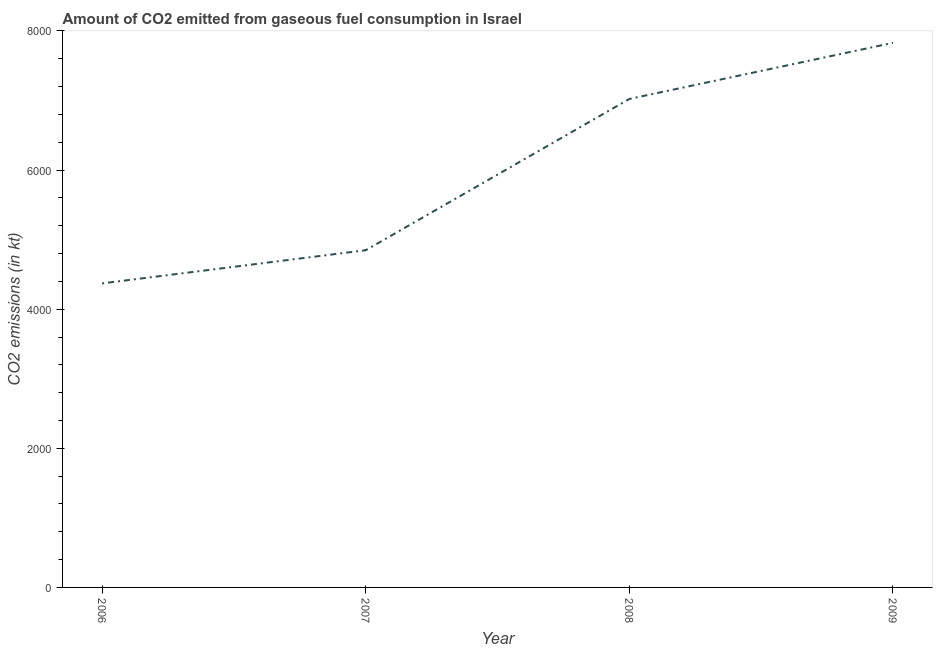What is the co2 emissions from gaseous fuel consumption in 2006?
Keep it short and to the point. 4371.06. Across all years, what is the maximum co2 emissions from gaseous fuel consumption?
Make the answer very short. 7829.05. Across all years, what is the minimum co2 emissions from gaseous fuel consumption?
Keep it short and to the point. 4371.06. In which year was the co2 emissions from gaseous fuel consumption maximum?
Your response must be concise. 2009. What is the sum of the co2 emissions from gaseous fuel consumption?
Your response must be concise. 2.41e+04. What is the difference between the co2 emissions from gaseous fuel consumption in 2007 and 2008?
Your answer should be very brief. -2174.53. What is the average co2 emissions from gaseous fuel consumption per year?
Your response must be concise. 6017.55. What is the median co2 emissions from gaseous fuel consumption?
Provide a short and direct response. 5935.04. In how many years, is the co2 emissions from gaseous fuel consumption greater than 5600 kt?
Give a very brief answer. 2. What is the ratio of the co2 emissions from gaseous fuel consumption in 2007 to that in 2009?
Offer a very short reply. 0.62. Is the difference between the co2 emissions from gaseous fuel consumption in 2007 and 2008 greater than the difference between any two years?
Give a very brief answer. No. What is the difference between the highest and the second highest co2 emissions from gaseous fuel consumption?
Offer a very short reply. 806.74. Is the sum of the co2 emissions from gaseous fuel consumption in 2007 and 2009 greater than the maximum co2 emissions from gaseous fuel consumption across all years?
Offer a very short reply. Yes. What is the difference between the highest and the lowest co2 emissions from gaseous fuel consumption?
Make the answer very short. 3457.98. In how many years, is the co2 emissions from gaseous fuel consumption greater than the average co2 emissions from gaseous fuel consumption taken over all years?
Your answer should be very brief. 2. How many lines are there?
Provide a succinct answer. 1. How many years are there in the graph?
Keep it short and to the point. 4. Does the graph contain any zero values?
Your answer should be compact. No. What is the title of the graph?
Keep it short and to the point. Amount of CO2 emitted from gaseous fuel consumption in Israel. What is the label or title of the X-axis?
Your response must be concise. Year. What is the label or title of the Y-axis?
Your answer should be compact. CO2 emissions (in kt). What is the CO2 emissions (in kt) of 2006?
Keep it short and to the point. 4371.06. What is the CO2 emissions (in kt) in 2007?
Your answer should be very brief. 4847.77. What is the CO2 emissions (in kt) in 2008?
Offer a very short reply. 7022.31. What is the CO2 emissions (in kt) in 2009?
Keep it short and to the point. 7829.05. What is the difference between the CO2 emissions (in kt) in 2006 and 2007?
Give a very brief answer. -476.71. What is the difference between the CO2 emissions (in kt) in 2006 and 2008?
Give a very brief answer. -2651.24. What is the difference between the CO2 emissions (in kt) in 2006 and 2009?
Offer a terse response. -3457.98. What is the difference between the CO2 emissions (in kt) in 2007 and 2008?
Offer a terse response. -2174.53. What is the difference between the CO2 emissions (in kt) in 2007 and 2009?
Give a very brief answer. -2981.27. What is the difference between the CO2 emissions (in kt) in 2008 and 2009?
Your answer should be compact. -806.74. What is the ratio of the CO2 emissions (in kt) in 2006 to that in 2007?
Make the answer very short. 0.9. What is the ratio of the CO2 emissions (in kt) in 2006 to that in 2008?
Offer a terse response. 0.62. What is the ratio of the CO2 emissions (in kt) in 2006 to that in 2009?
Your response must be concise. 0.56. What is the ratio of the CO2 emissions (in kt) in 2007 to that in 2008?
Provide a short and direct response. 0.69. What is the ratio of the CO2 emissions (in kt) in 2007 to that in 2009?
Your response must be concise. 0.62. What is the ratio of the CO2 emissions (in kt) in 2008 to that in 2009?
Provide a succinct answer. 0.9. 